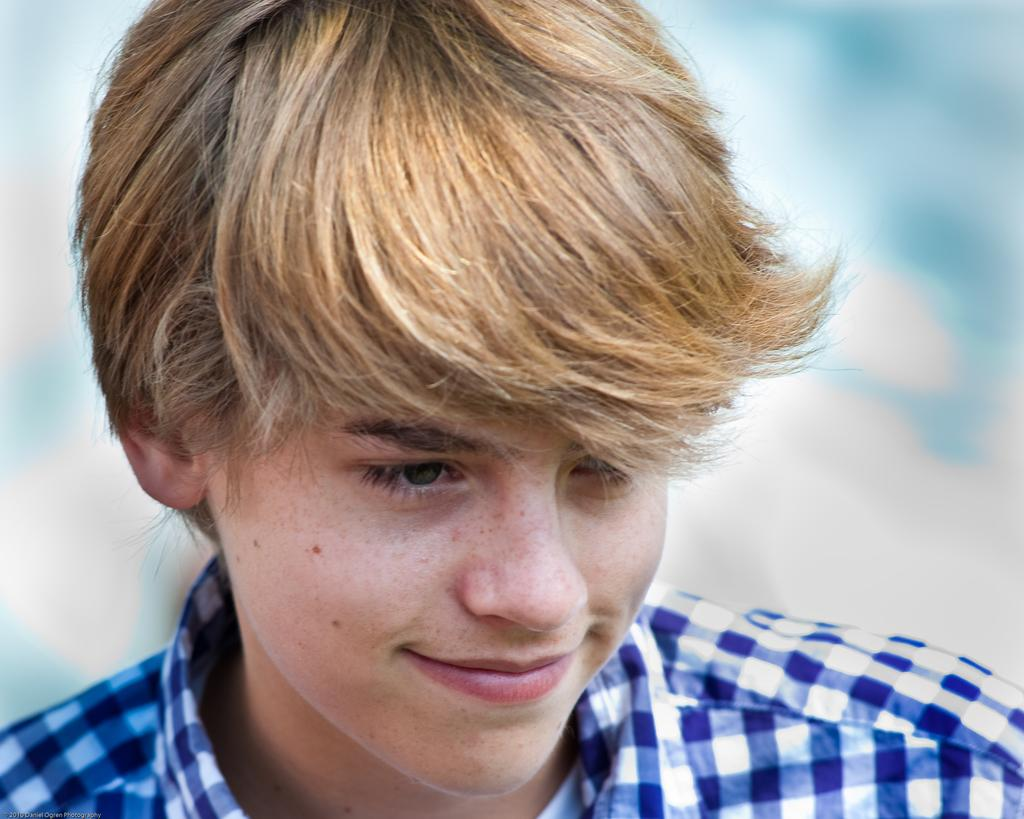Who is present in the image? There is a man in the image. Can you describe the background of the image? The background of the image is blurry. What type of guitar is the man playing in the image? There is no guitar present in the image; it only features a man and a blurry background. 